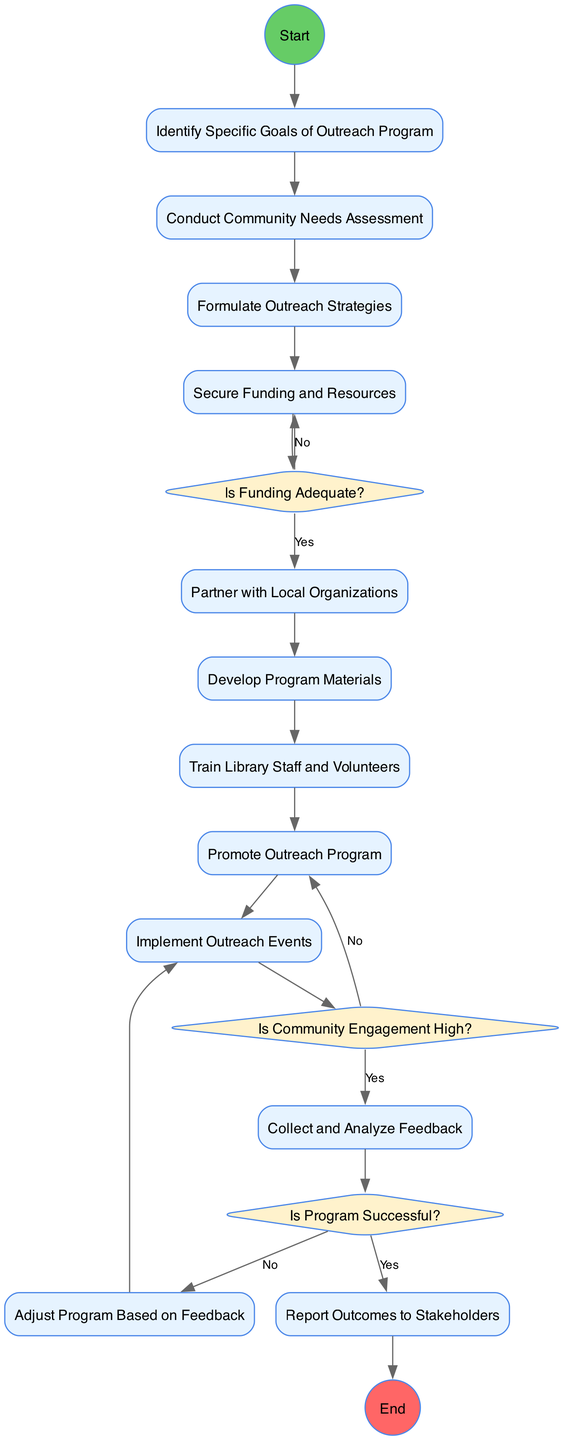What is the first activity in the diagram? The first activity in the diagram follows the start node and is labeled as "Identify Specific Goals of Outreach Program." This is represented as the first flow coming out of the start node.
Answer: Identify Specific Goals of Outreach Program How many main activities are there in the diagram? The diagram lists a total of 12 activities, as indicated in the "Activities" section of the data. Each activity is clearly identified with a unique ID.
Answer: 12 What decision node assesses funding adequacy? The decision node that evaluates funding adequacy is labeled "Is Funding Adequate?" It is directly connected to the activity for securing funding, creating a checkpoint for the program's financial viability.
Answer: Is Funding Adequate? What are the two outcomes from the decision on community engagement? The outcomes from the decision node labeled "Is Community Engagement High?" can either lead to collecting and analyzing feedback (if yes) or back to promoting the outreach program (if no). This bifurcation reflects whether the program successfully engaged the community.
Answer: Collect and Analyze Feedback, Promote Outreach Program After receiving feedback, what is the next action if the program is deemed successful? If the program is deemed successful according to the decision node "Is Program Successful?", the next action is to report outcomes to stakeholders. This indicates the closing of the program cycle with necessary communications back to those involved.
Answer: Report Outcomes to Stakeholders What happens if funding is inadequate? If funding is inadequate, indicated by a "No" decision from "Is Funding Adequate?", the flow returns to the activity "Secure Funding and Resources," implying that the planning process must revisit funding options.
Answer: Secure Funding and Resources What activity follows the training of staff and volunteers? The activity that follows the training of library staff and volunteers is labeled "Promote Outreach Program." This step emphasizes the importance of spreading awareness after adequately preparing the staff for outreach efforts.
Answer: Promote Outreach Program Which activity immediately precedes the implementation of outreach events? The activity that directly precedes the implementation of outreach events is "Promote Outreach Program." This shows that prior promotion is necessary before executing the actual outreach activities.
Answer: Promote Outreach Program 